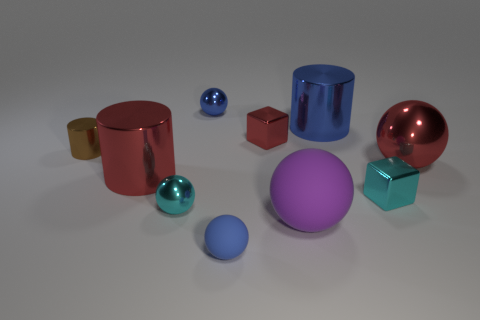How many objects are either small blue objects behind the large rubber thing or shiny things to the left of the red metal sphere?
Offer a terse response. 7. There is a blue metallic thing that is to the left of the purple rubber thing; is it the same size as the blue matte object?
Provide a succinct answer. Yes. The shiny cylinder that is to the right of the tiny blue rubber sphere is what color?
Provide a succinct answer. Blue. There is another large matte object that is the same shape as the blue rubber object; what color is it?
Provide a short and direct response. Purple. There is a large red thing to the right of the small cyan shiny object that is on the right side of the blue metal sphere; what number of shiny cubes are behind it?
Keep it short and to the point. 1. Are there any other things that are the same material as the large blue cylinder?
Ensure brevity in your answer.  Yes. Are there fewer tiny metallic cubes behind the red sphere than shiny cylinders?
Provide a short and direct response. Yes. Is the small matte sphere the same color as the large shiny sphere?
Your answer should be very brief. No. There is another object that is the same shape as the tiny red thing; what is its size?
Offer a very short reply. Small. How many red things are the same material as the tiny brown object?
Keep it short and to the point. 3. 